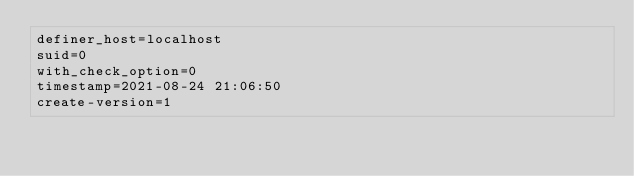<code> <loc_0><loc_0><loc_500><loc_500><_VisualBasic_>definer_host=localhost
suid=0
with_check_option=0
timestamp=2021-08-24 21:06:50
create-version=1</code> 